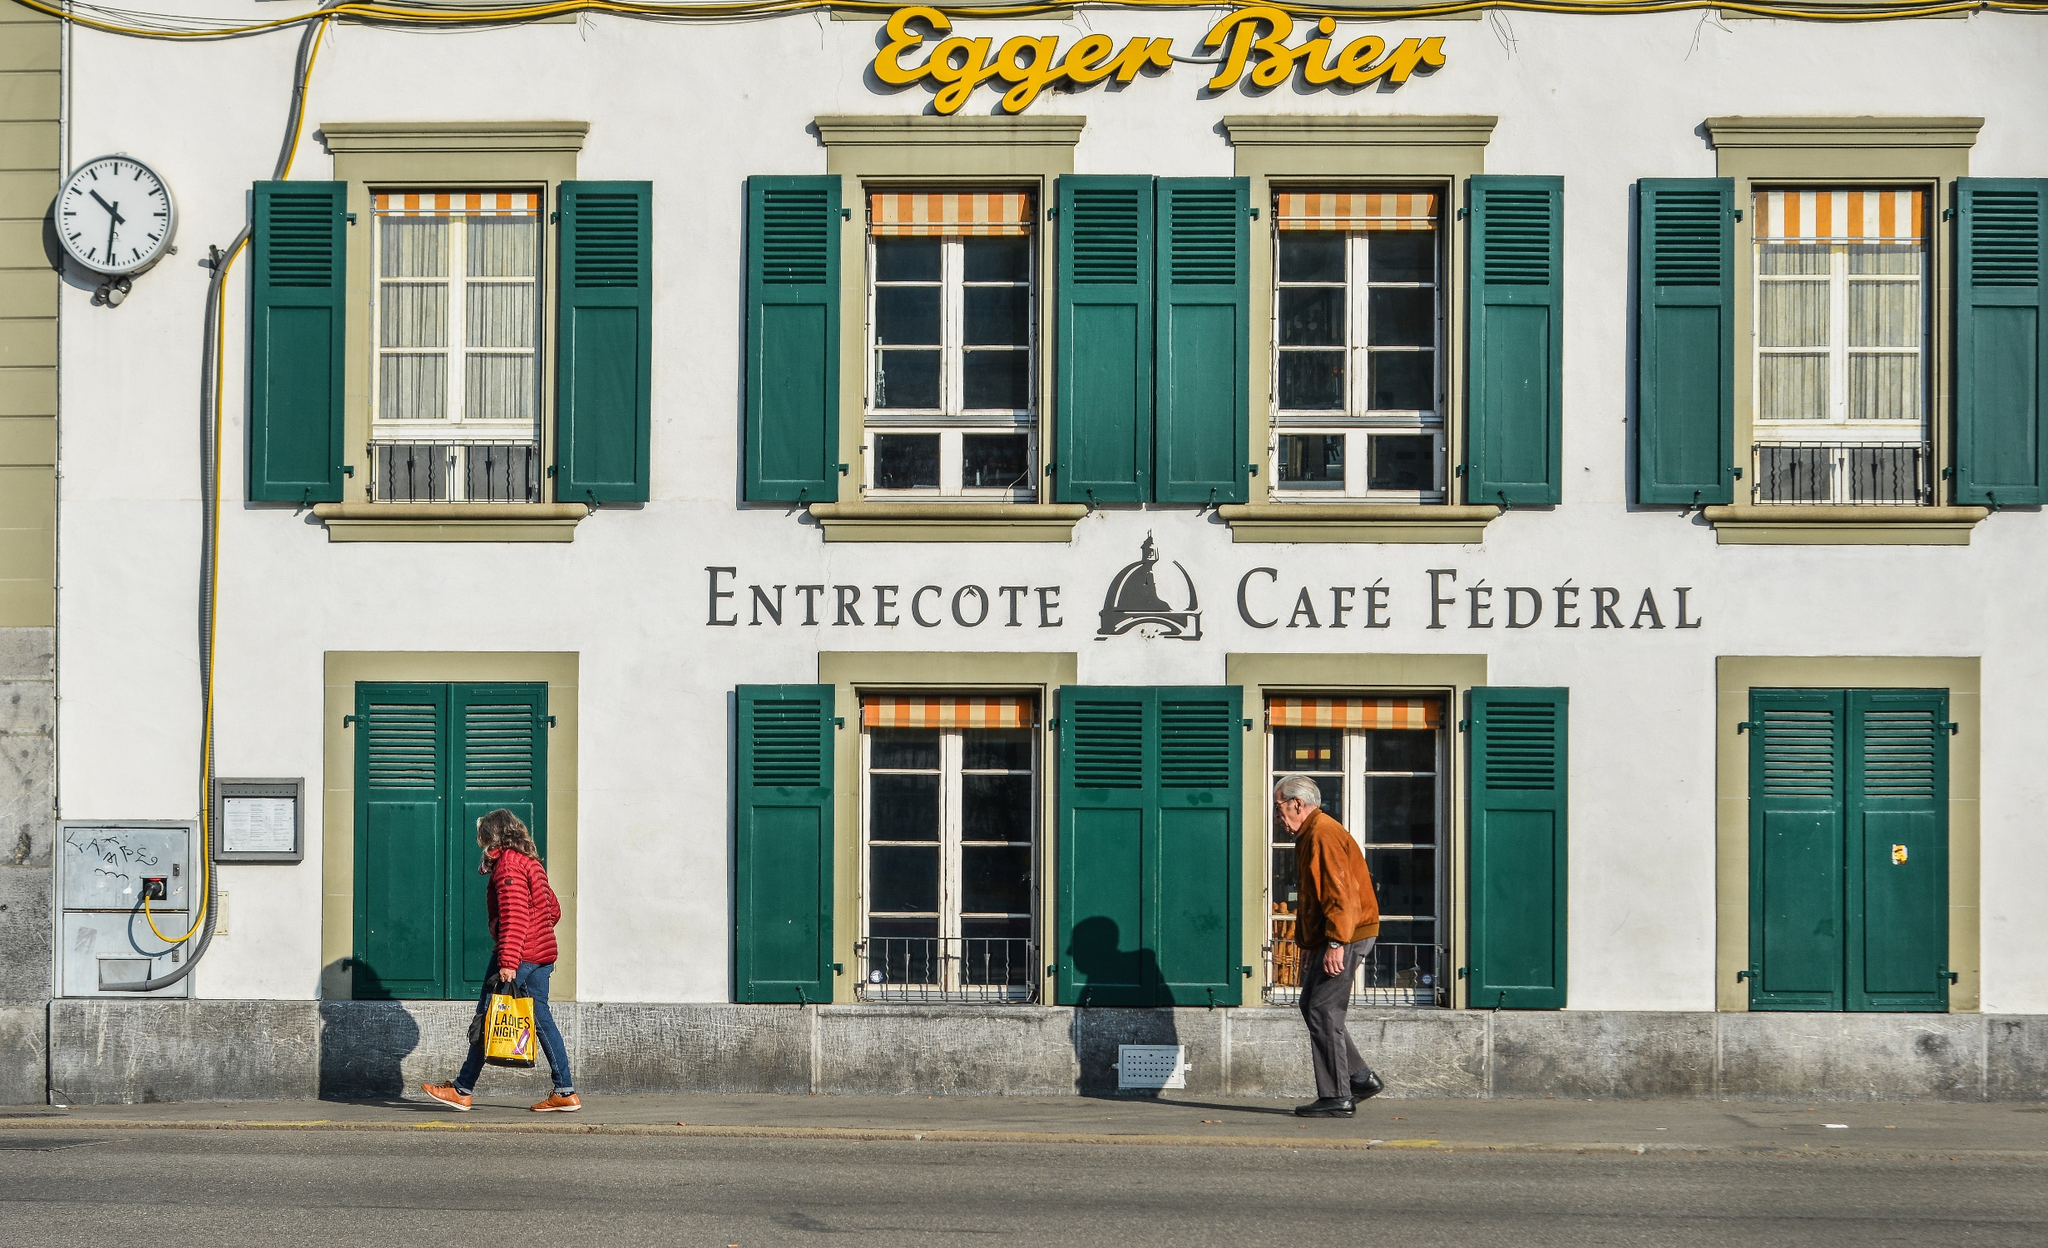Describe a typical day at 'Entrecote Café Fédéral' from morning until night. A typical day at 'Entrecote Café Fédéral' begins in the early morning as the first light illuminates the quaint Swiss street. Patrons drift in for a hearty breakfast, filling the air with the rich aroma of freshly brewed coffee and baked goods. As the day progresses, the café buzzes with an eclectic mix of locals and tourists savoring a variety of Swiss culinary delights. The outdoor seating becomes a popular spot to bask under the sun, with laughter and conversation mixing with the gentle hum of the town. By the afternoon, the Café transitions seamlessly to serve exquisite lunches, featuring their famed entrecote steaks. As the sun sets, the café adopts a more serene ambiance. The warm, dim lights inside accentuate the coziness, inviting guests to unwind with a glass of wine or a steaming cup of tea. Finally, night falls, and the café closes its doors, ready to rejuvenate for another day of welcoming smiles and delicious food. 